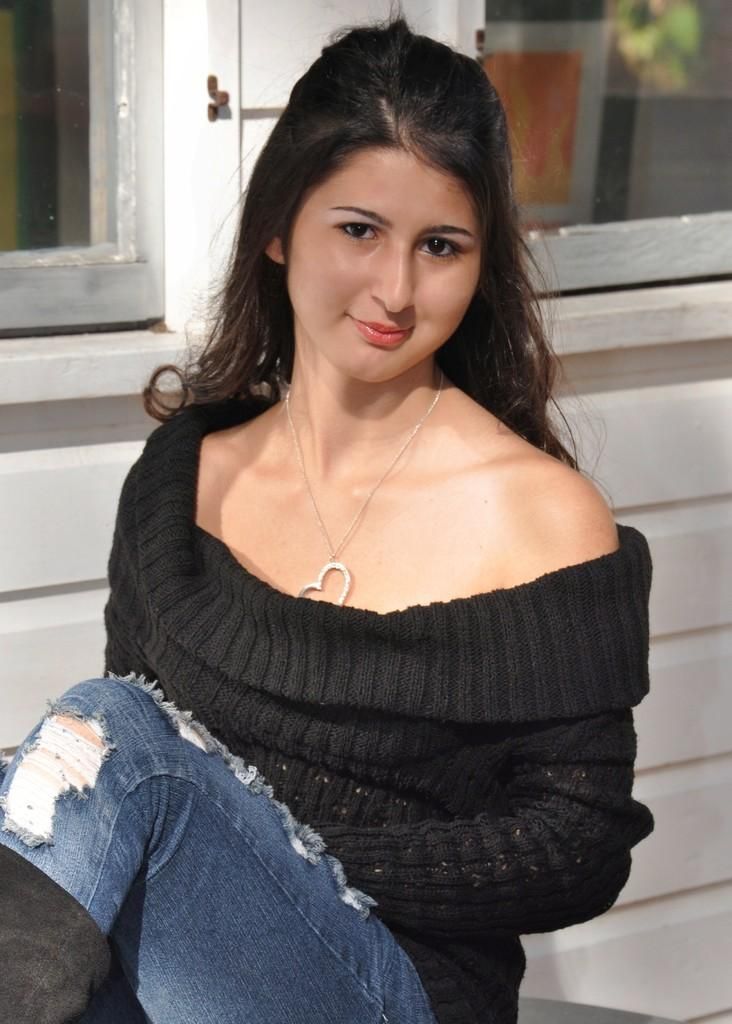Who is the main subject in the image? There is a lady in the image. What is the lady wearing on her upper body? The lady is wearing a black top. What type of pants is the lady wearing? The lady is wearing blue jeans. What can be seen in the background of the image? There is a white wall in the background of the image. What object is present in the image that is typically used for seeing? There are glasses in the image. Is the lady wearing a crown in the image? No, the lady is not wearing a crown in the image. What type of memory is the lady trying to recall in the image? There is no indication in the image that the lady is trying to recall any memory. 